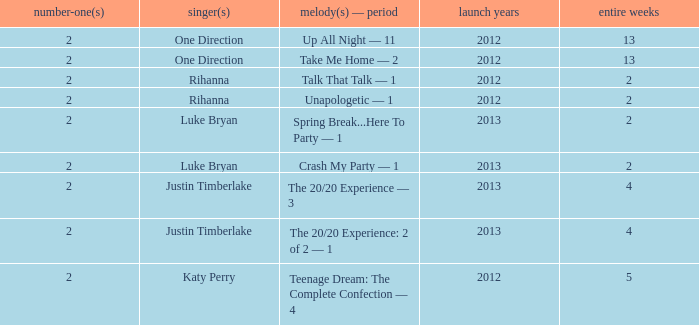What is the title of every song, and how many weeks was each song at #1 for One Direction? Up All Night — 11, Take Me Home — 2. 